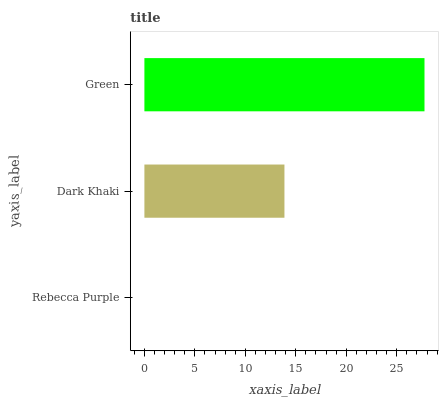Is Rebecca Purple the minimum?
Answer yes or no. Yes. Is Green the maximum?
Answer yes or no. Yes. Is Dark Khaki the minimum?
Answer yes or no. No. Is Dark Khaki the maximum?
Answer yes or no. No. Is Dark Khaki greater than Rebecca Purple?
Answer yes or no. Yes. Is Rebecca Purple less than Dark Khaki?
Answer yes or no. Yes. Is Rebecca Purple greater than Dark Khaki?
Answer yes or no. No. Is Dark Khaki less than Rebecca Purple?
Answer yes or no. No. Is Dark Khaki the high median?
Answer yes or no. Yes. Is Dark Khaki the low median?
Answer yes or no. Yes. Is Rebecca Purple the high median?
Answer yes or no. No. Is Green the low median?
Answer yes or no. No. 